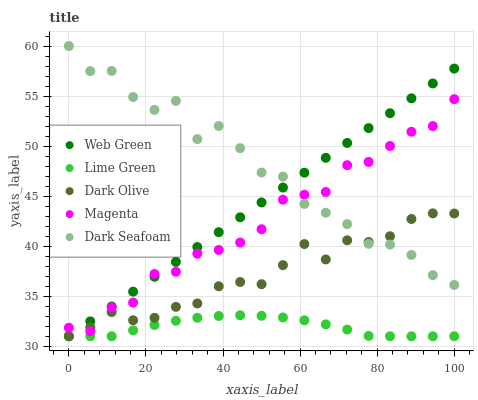Does Lime Green have the minimum area under the curve?
Answer yes or no. Yes. Does Dark Seafoam have the maximum area under the curve?
Answer yes or no. Yes. Does Dark Olive have the minimum area under the curve?
Answer yes or no. No. Does Dark Olive have the maximum area under the curve?
Answer yes or no. No. Is Web Green the smoothest?
Answer yes or no. Yes. Is Dark Seafoam the roughest?
Answer yes or no. Yes. Is Dark Olive the smoothest?
Answer yes or no. No. Is Dark Olive the roughest?
Answer yes or no. No. Does Dark Olive have the lowest value?
Answer yes or no. Yes. Does Dark Seafoam have the lowest value?
Answer yes or no. No. Does Dark Seafoam have the highest value?
Answer yes or no. Yes. Does Dark Olive have the highest value?
Answer yes or no. No. Is Lime Green less than Magenta?
Answer yes or no. Yes. Is Dark Seafoam greater than Lime Green?
Answer yes or no. Yes. Does Lime Green intersect Web Green?
Answer yes or no. Yes. Is Lime Green less than Web Green?
Answer yes or no. No. Is Lime Green greater than Web Green?
Answer yes or no. No. Does Lime Green intersect Magenta?
Answer yes or no. No. 